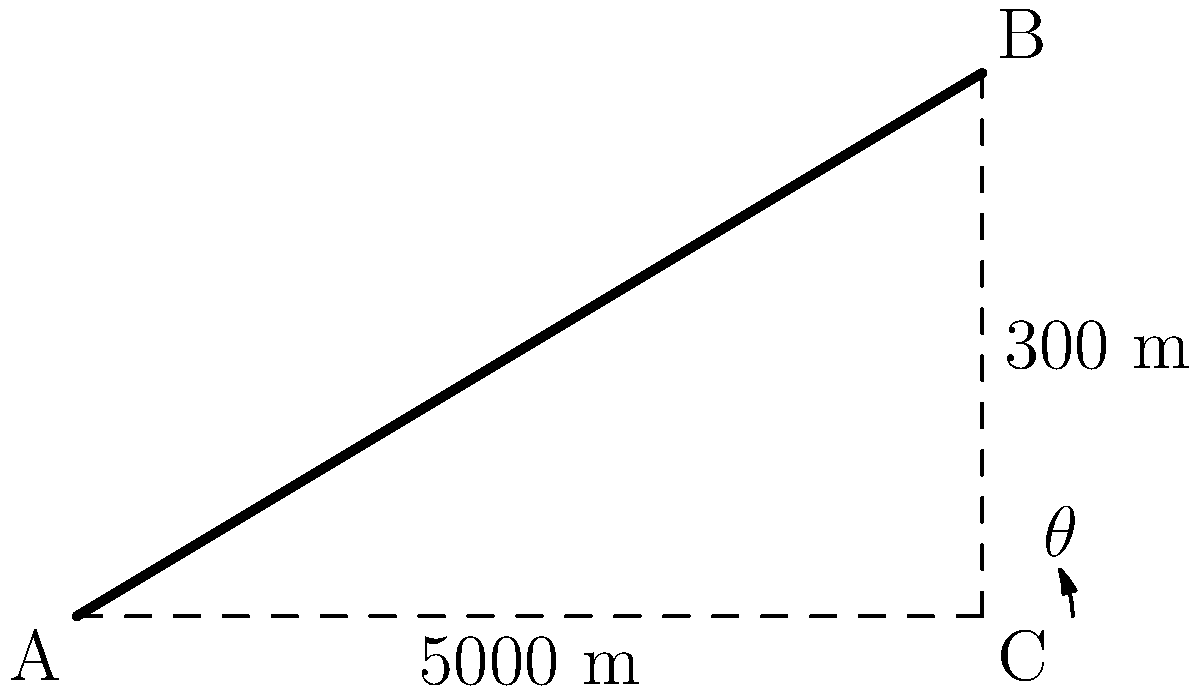A new high-speed rail route is being planned through a mountainous region. The engineers need to calculate the grade angle of the track for a specific section. Given that the horizontal distance of this section is 5000 meters, and the elevation gain is 300 meters, what is the grade angle $\theta$ of the track to the nearest tenth of a degree? To solve this problem, we'll follow these steps:

1) First, we need to understand what grade angle means. It's the angle between the slope of the track and the horizontal plane.

2) We can use trigonometry to find this angle. We have a right triangle where:
   - The adjacent side (horizontal distance) is 5000 meters
   - The opposite side (elevation gain) is 300 meters

3) To find the angle, we'll use the tangent function:

   $\tan(\theta) = \frac{\text{opposite}}{\text{adjacent}} = \frac{\text{elevation gain}}{\text{horizontal distance}}$

4) Let's substitute our values:

   $\tan(\theta) = \frac{300}{5000} = 0.06$

5) To find $\theta$, we need to use the inverse tangent (arctangent) function:

   $\theta = \arctan(0.06)$

6) Using a calculator or computer:

   $\theta \approx 3.4349775$ degrees

7) Rounding to the nearest tenth of a degree:

   $\theta \approx 3.4$ degrees

Therefore, the grade angle of the track is approximately 3.4 degrees.
Answer: $3.4°$ 